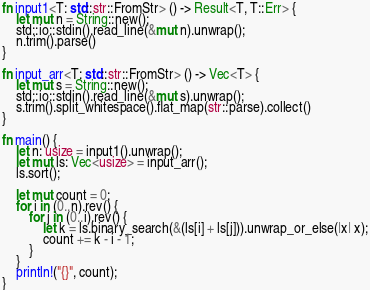Convert code to text. <code><loc_0><loc_0><loc_500><loc_500><_Rust_>fn input1<T: std::str::FromStr> () -> Result<T, T::Err> {
    let mut n = String::new();
    std::io::stdin().read_line(&mut n).unwrap();
    n.trim().parse()
}

fn input_arr<T: std::str::FromStr> () -> Vec<T> {
    let mut s = String::new();
    std::io::stdin().read_line(&mut s).unwrap();
    s.trim().split_whitespace().flat_map(str::parse).collect()
}

fn main() {
    let n: usize = input1().unwrap();
    let mut ls: Vec<usize> = input_arr();
    ls.sort();

    let mut count = 0;
    for i in (0..n).rev() {
        for j in (0..i).rev() {
            let k = ls.binary_search(&(ls[i] + ls[j])).unwrap_or_else(|x| x);
            count += k - i - 1;
        }
    }
    println!("{}", count);
}
</code> 